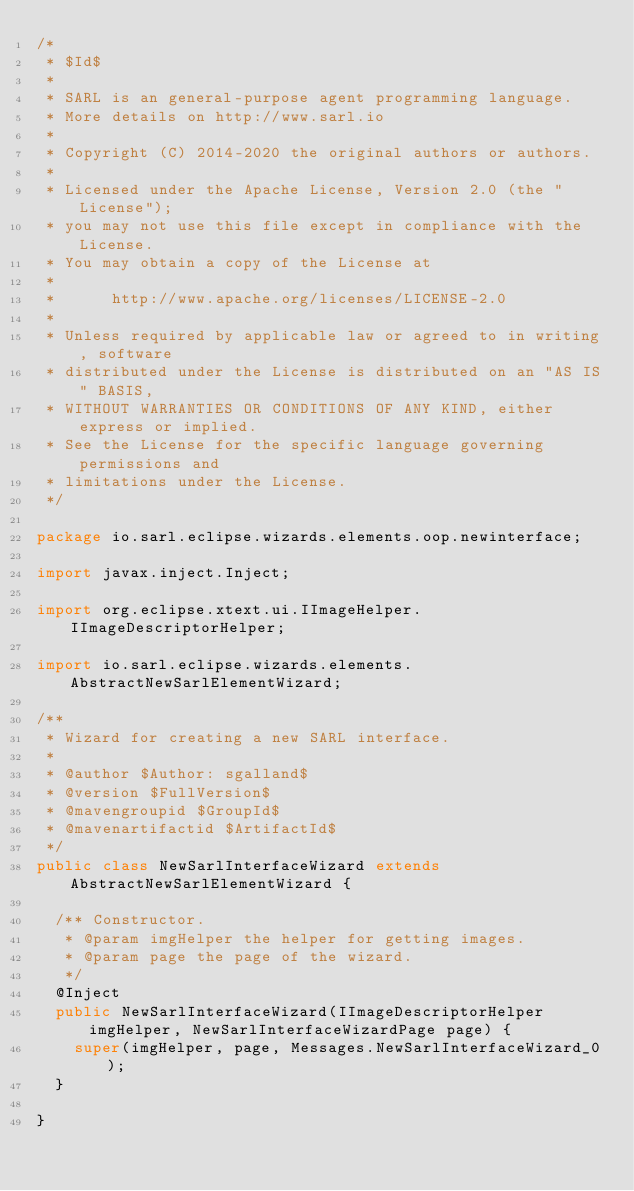<code> <loc_0><loc_0><loc_500><loc_500><_Java_>/*
 * $Id$
 *
 * SARL is an general-purpose agent programming language.
 * More details on http://www.sarl.io
 *
 * Copyright (C) 2014-2020 the original authors or authors.
 *
 * Licensed under the Apache License, Version 2.0 (the "License");
 * you may not use this file except in compliance with the License.
 * You may obtain a copy of the License at
 *
 *      http://www.apache.org/licenses/LICENSE-2.0
 *
 * Unless required by applicable law or agreed to in writing, software
 * distributed under the License is distributed on an "AS IS" BASIS,
 * WITHOUT WARRANTIES OR CONDITIONS OF ANY KIND, either express or implied.
 * See the License for the specific language governing permissions and
 * limitations under the License.
 */

package io.sarl.eclipse.wizards.elements.oop.newinterface;

import javax.inject.Inject;

import org.eclipse.xtext.ui.IImageHelper.IImageDescriptorHelper;

import io.sarl.eclipse.wizards.elements.AbstractNewSarlElementWizard;

/**
 * Wizard for creating a new SARL interface.
 *
 * @author $Author: sgalland$
 * @version $FullVersion$
 * @mavengroupid $GroupId$
 * @mavenartifactid $ArtifactId$
 */
public class NewSarlInterfaceWizard extends AbstractNewSarlElementWizard {

	/** Constructor.
	 * @param imgHelper the helper for getting images.
	 * @param page the page of the wizard.
	 */
	@Inject
	public NewSarlInterfaceWizard(IImageDescriptorHelper imgHelper, NewSarlInterfaceWizardPage page) {
		super(imgHelper, page, Messages.NewSarlInterfaceWizard_0);
	}

}
</code> 